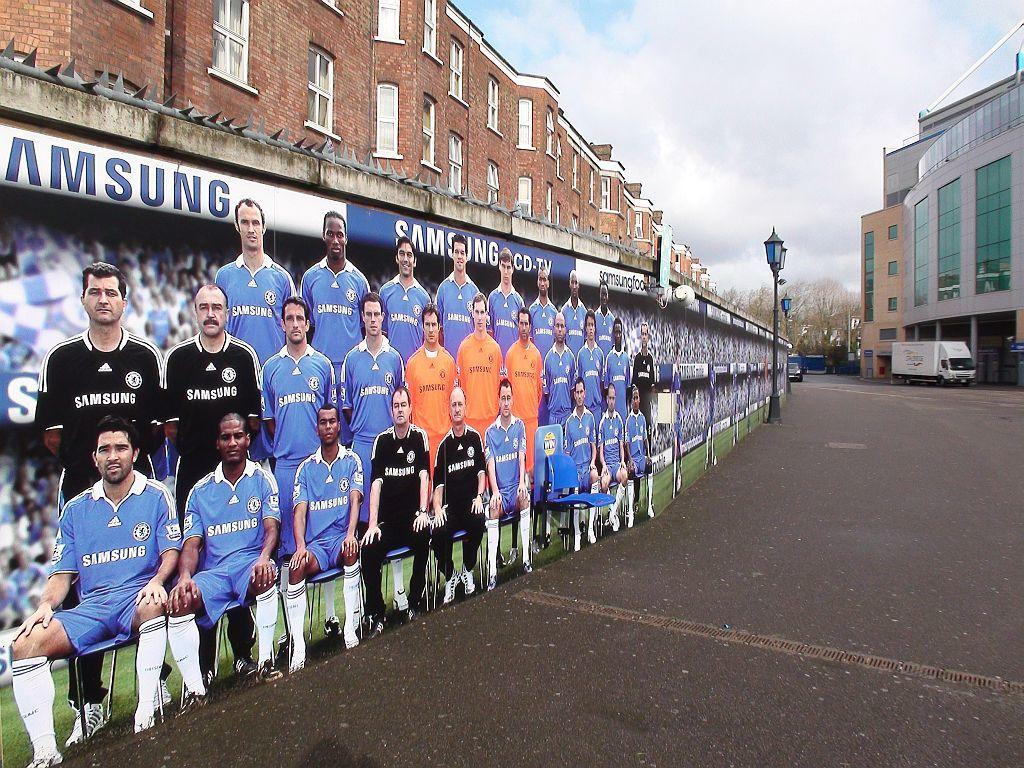<image>
Relay a brief, clear account of the picture shown. Poster of a bunch of soccer players that are wearing Samsung shirts. 